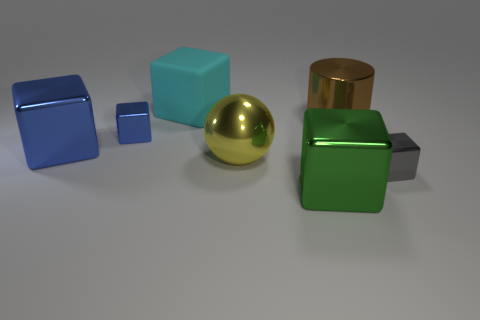How many objects are there, and can you describe their colors and materials? There are five objects in total, each with a distinct color and material. From left to right, we have a blue glossy cube, a cyan matte cube, a gold shiny sphere, a green glossy cube, and a grey matte cube. 